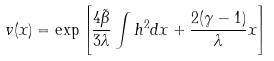Convert formula to latex. <formula><loc_0><loc_0><loc_500><loc_500>v ( x ) = \exp { \left [ \frac { 4 \tilde { \beta } } { 3 \lambda } \int h ^ { 2 } d x + \frac { 2 ( \gamma - 1 ) } { \lambda } x \right ] }</formula> 